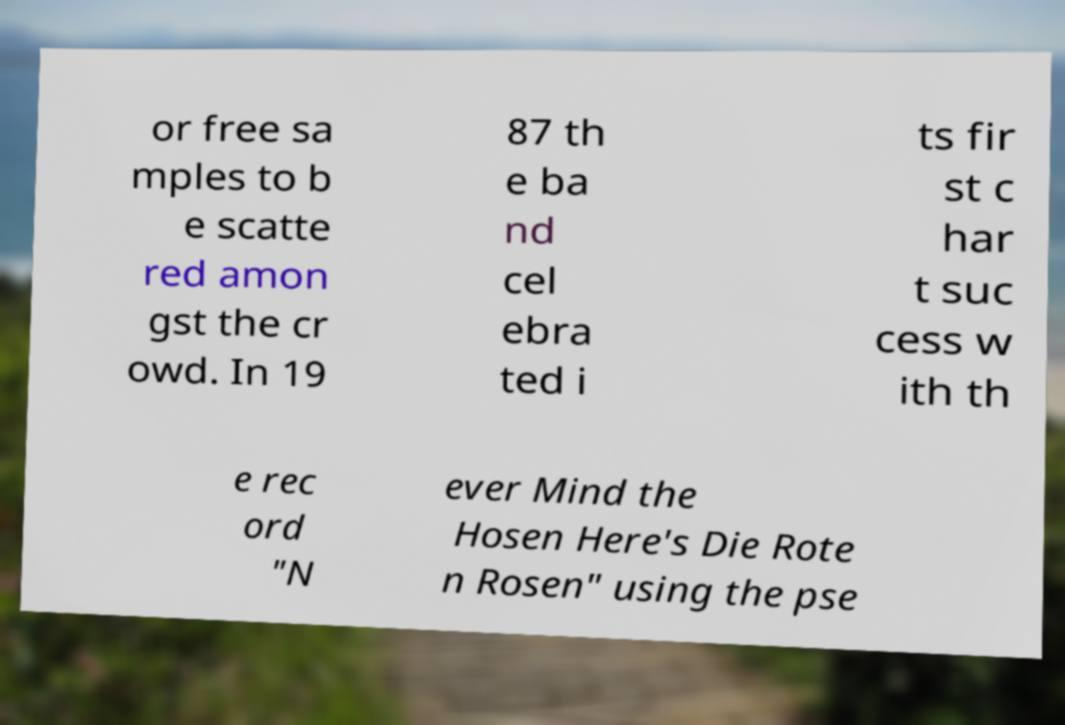I need the written content from this picture converted into text. Can you do that? or free sa mples to b e scatte red amon gst the cr owd. In 19 87 th e ba nd cel ebra ted i ts fir st c har t suc cess w ith th e rec ord "N ever Mind the Hosen Here's Die Rote n Rosen" using the pse 